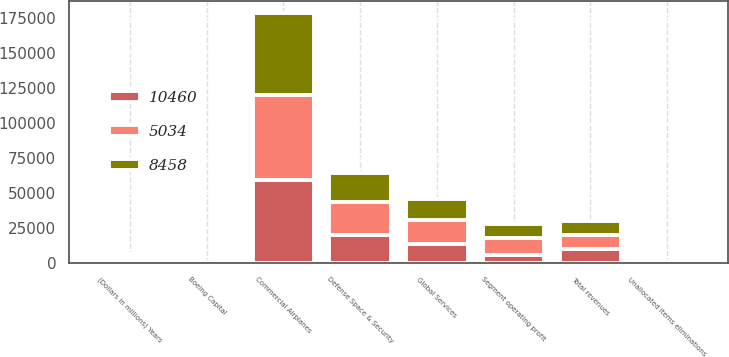Convert chart to OTSL. <chart><loc_0><loc_0><loc_500><loc_500><stacked_bar_chart><ecel><fcel>(Dollars in millions) Years<fcel>Commercial Airplanes<fcel>Defense Space & Security<fcel>Global Services<fcel>Boeing Capital<fcel>Unallocated items eliminations<fcel>Total revenues<fcel>Segment operating profit<nl><fcel>5034<fcel>2018<fcel>60715<fcel>23195<fcel>17018<fcel>274<fcel>75<fcel>10005<fcel>12074<nl><fcel>8458<fcel>2017<fcel>58014<fcel>20561<fcel>14581<fcel>307<fcel>542<fcel>10005<fcel>10005<nl><fcel>10460<fcel>2016<fcel>59378<fcel>20180<fcel>13819<fcel>298<fcel>179<fcel>10005<fcel>5877<nl></chart> 